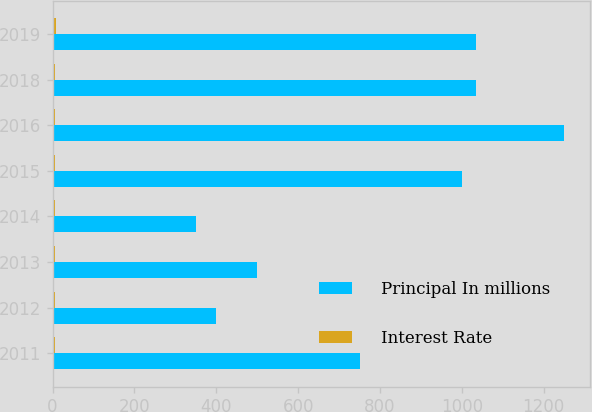<chart> <loc_0><loc_0><loc_500><loc_500><stacked_bar_chart><ecel><fcel>2011<fcel>2012<fcel>2013<fcel>2014<fcel>2015<fcel>2016<fcel>2018<fcel>2019<nl><fcel>Principal In millions<fcel>750<fcel>400<fcel>500<fcel>350<fcel>1000<fcel>1250<fcel>1035<fcel>1035<nl><fcel>Interest Rate<fcel>6.13<fcel>5.38<fcel>5<fcel>5.5<fcel>5<fcel>6.75<fcel>6.82<fcel>7.72<nl></chart> 